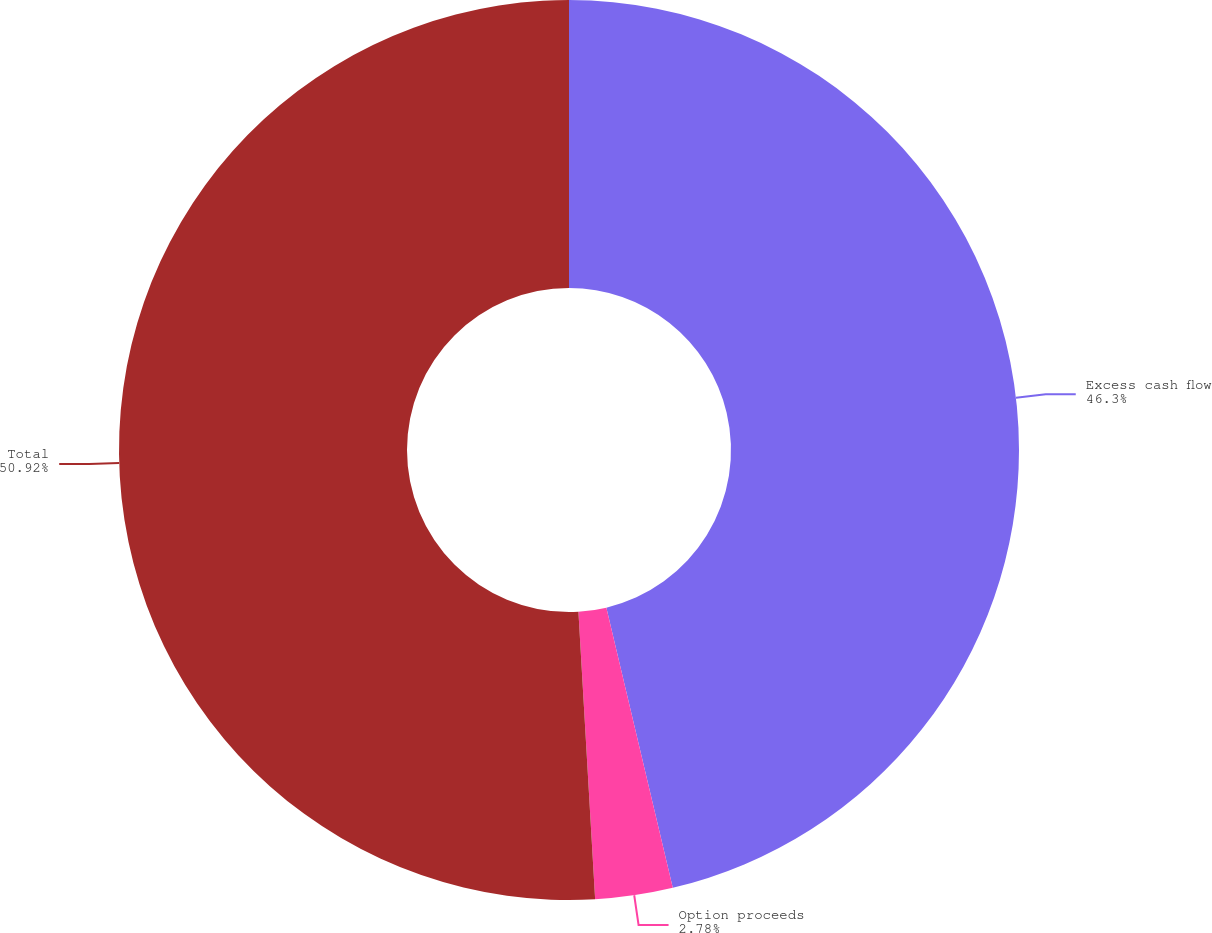Convert chart. <chart><loc_0><loc_0><loc_500><loc_500><pie_chart><fcel>Excess cash flow<fcel>Option proceeds<fcel>Total<nl><fcel>46.3%<fcel>2.78%<fcel>50.93%<nl></chart> 